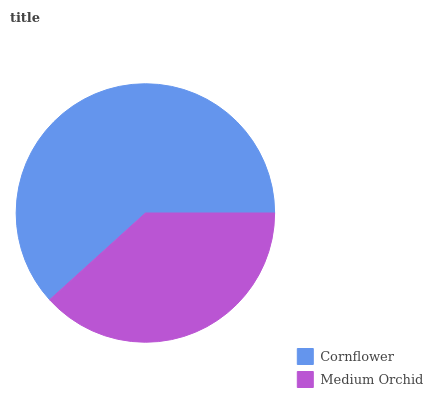Is Medium Orchid the minimum?
Answer yes or no. Yes. Is Cornflower the maximum?
Answer yes or no. Yes. Is Medium Orchid the maximum?
Answer yes or no. No. Is Cornflower greater than Medium Orchid?
Answer yes or no. Yes. Is Medium Orchid less than Cornflower?
Answer yes or no. Yes. Is Medium Orchid greater than Cornflower?
Answer yes or no. No. Is Cornflower less than Medium Orchid?
Answer yes or no. No. Is Cornflower the high median?
Answer yes or no. Yes. Is Medium Orchid the low median?
Answer yes or no. Yes. Is Medium Orchid the high median?
Answer yes or no. No. Is Cornflower the low median?
Answer yes or no. No. 